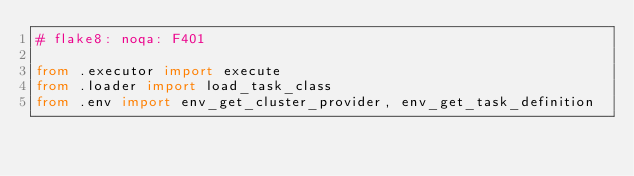Convert code to text. <code><loc_0><loc_0><loc_500><loc_500><_Python_># flake8: noqa: F401

from .executor import execute
from .loader import load_task_class
from .env import env_get_cluster_provider, env_get_task_definition
</code> 